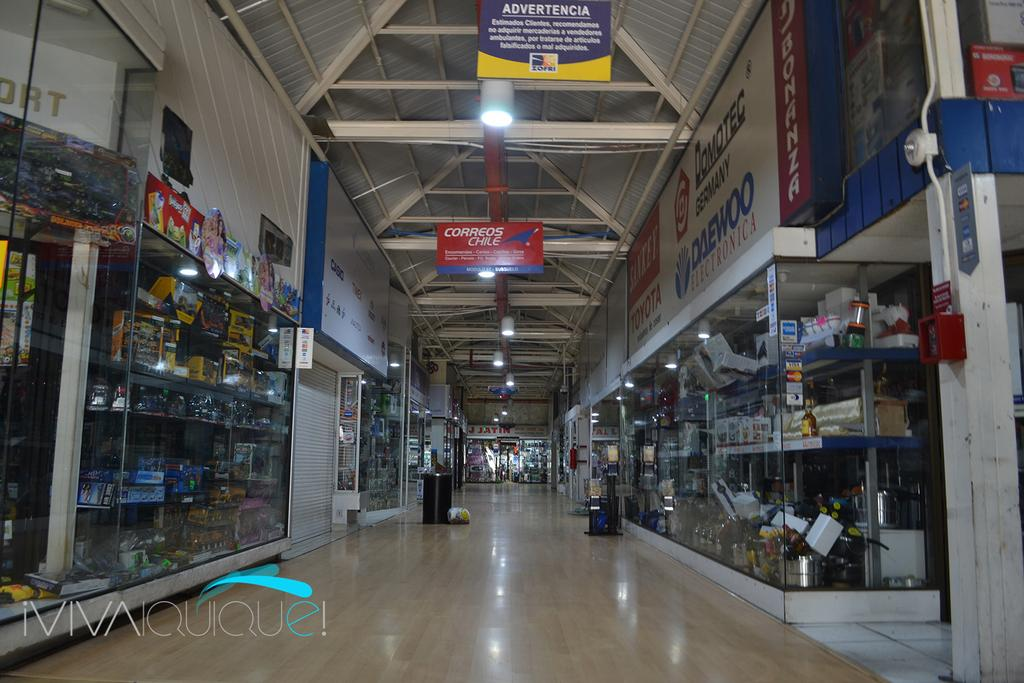<image>
Summarize the visual content of the image. the inside of a building with a sign up top that says correos chile on it 